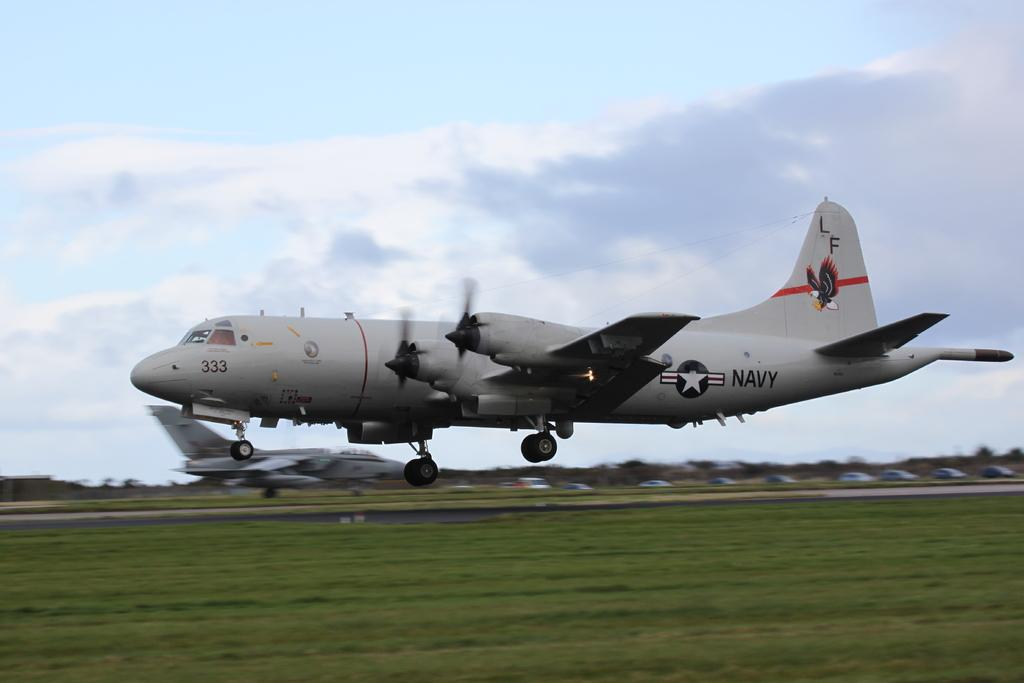<image>
Share a concise interpretation of the image provided. An airplane with the word Navy written on the side 